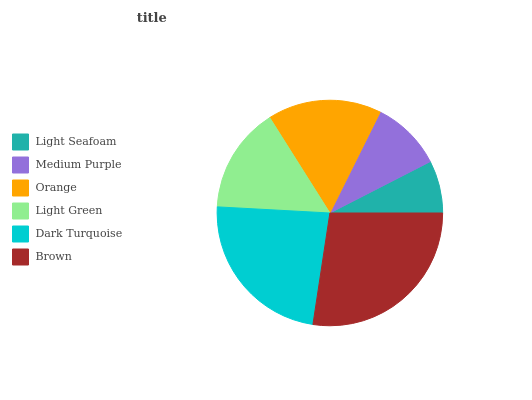Is Light Seafoam the minimum?
Answer yes or no. Yes. Is Brown the maximum?
Answer yes or no. Yes. Is Medium Purple the minimum?
Answer yes or no. No. Is Medium Purple the maximum?
Answer yes or no. No. Is Medium Purple greater than Light Seafoam?
Answer yes or no. Yes. Is Light Seafoam less than Medium Purple?
Answer yes or no. Yes. Is Light Seafoam greater than Medium Purple?
Answer yes or no. No. Is Medium Purple less than Light Seafoam?
Answer yes or no. No. Is Orange the high median?
Answer yes or no. Yes. Is Light Green the low median?
Answer yes or no. Yes. Is Medium Purple the high median?
Answer yes or no. No. Is Dark Turquoise the low median?
Answer yes or no. No. 